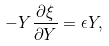<formula> <loc_0><loc_0><loc_500><loc_500>- Y \frac { \partial \xi } { \partial Y } = \epsilon Y ,</formula> 